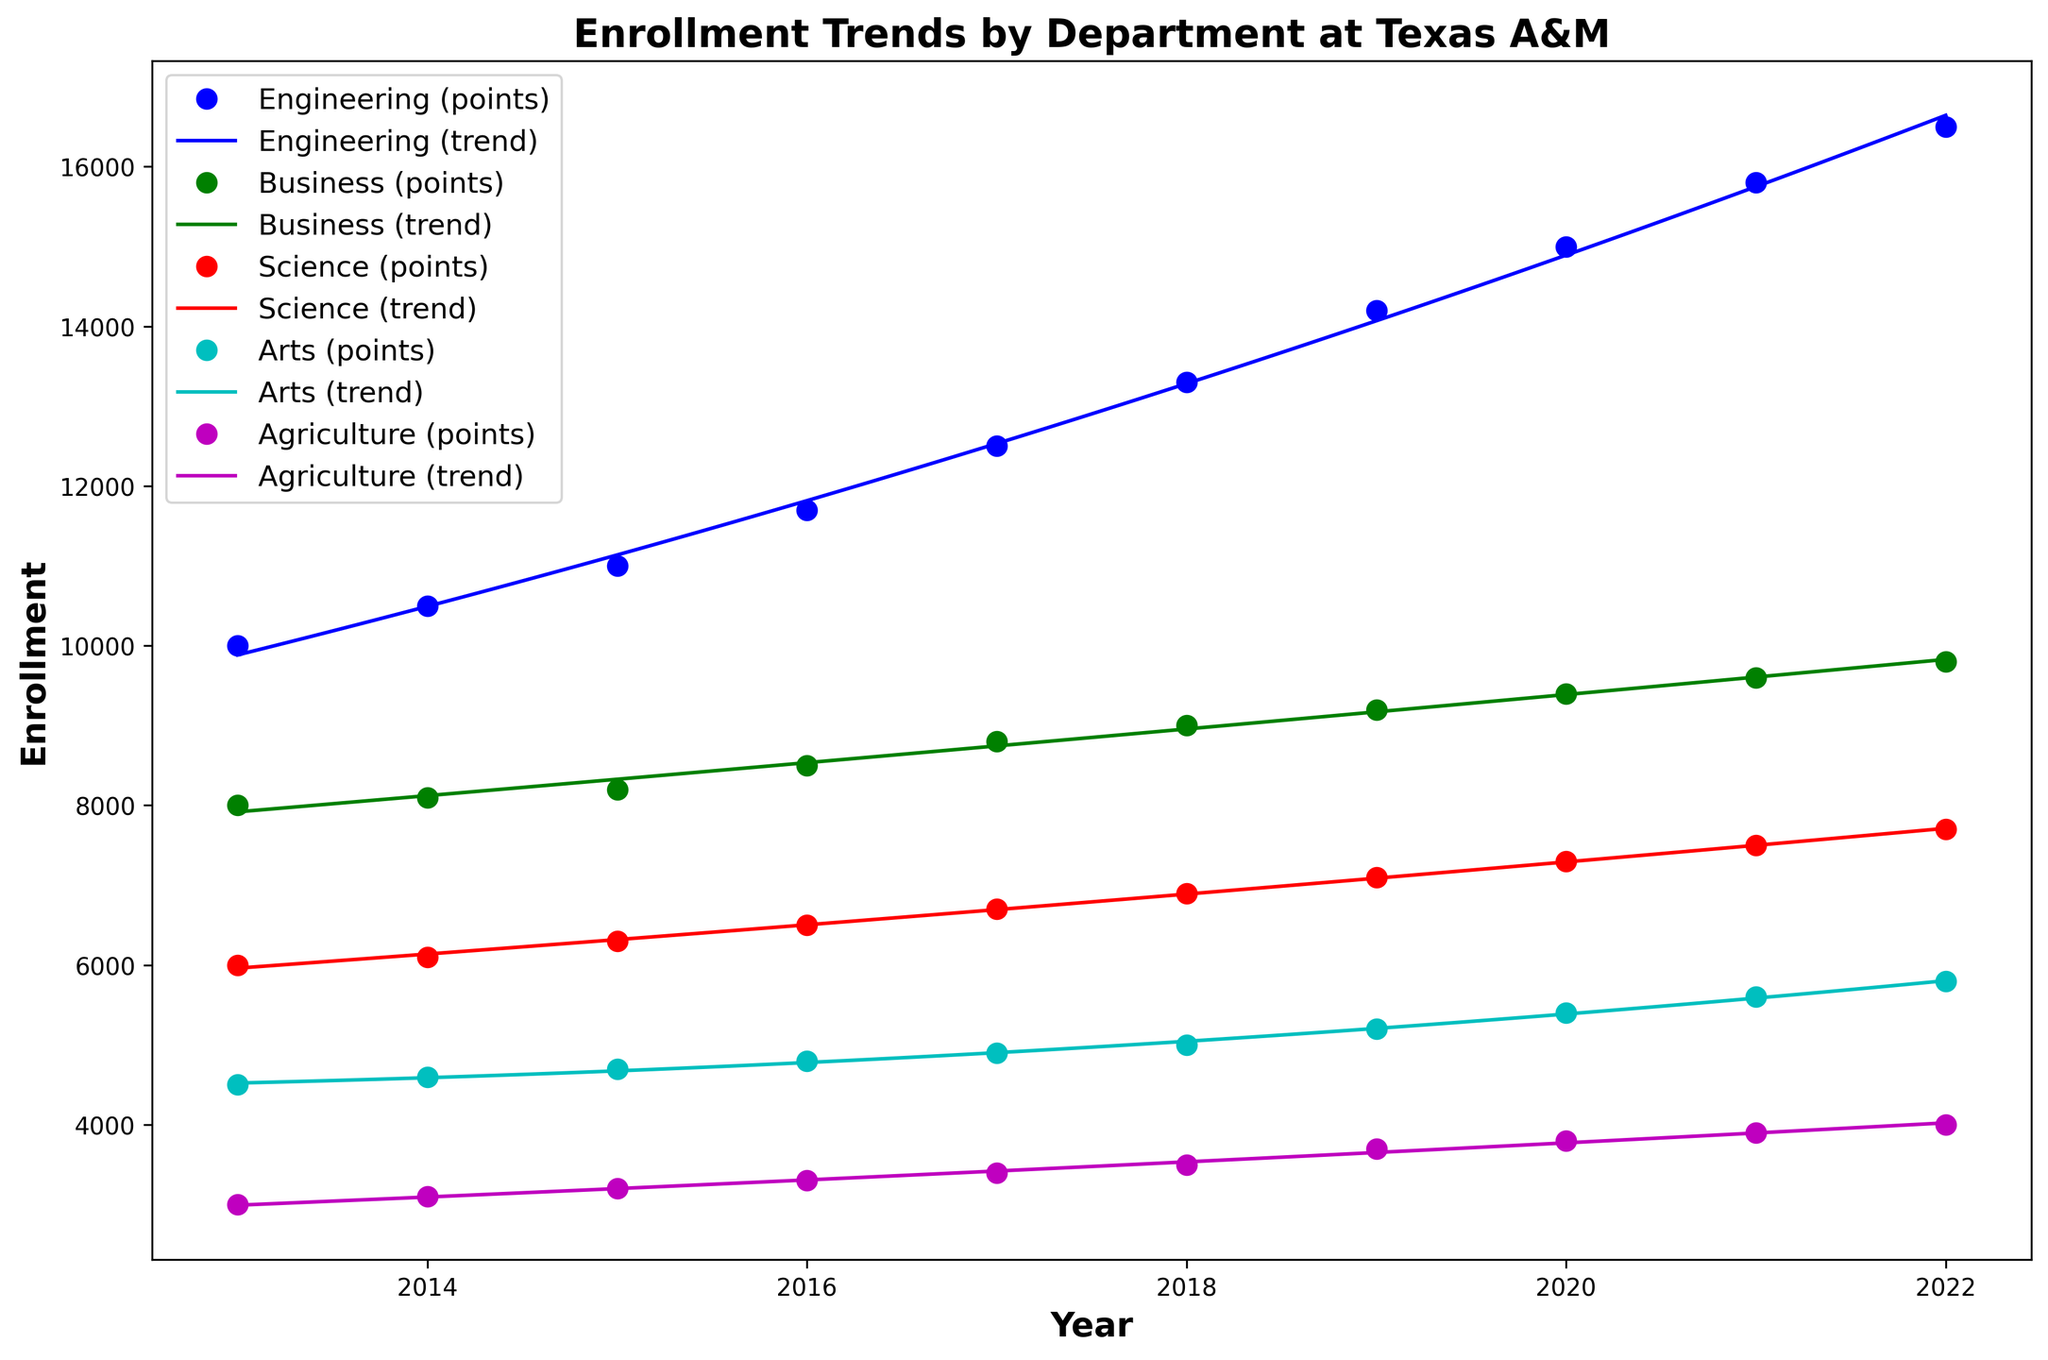Which department showed the highest enrollment increase from 2013 to 2022? By comparing the enrollment values in 2013 and 2022 for each department, Engineering had the largest difference. Engineering grew from 10,000 to 16,500, an increase of 6,500.
Answer: Engineering Which department had the smallest polynomial curve trend? By observing the curves, Agriculture's curve appears less steep compared to others, indicating a smaller increase in the trend over time.
Answer: Agriculture Among the departments, which one had the most consistent increase in enrollment over the years? The Business department shows a relatively stable and steady increase in the scatter points and fitted curve from 2013 to 2022.
Answer: Business What is the average enrollment in the Science department for the given years? The enrollment values for Science are [6000, 6100, 6300, 6500, 6700, 6900, 7100, 7300, 7500, 7700]. The sum of these values is 73100. Dividing by 10 years gives an average of 7310.
Answer: 7310 Based on visual trend lines, which two departments intersect in their polynomial trend curve, if at all? The polynomial trend lines for Business and Science appear to intersect around the year 2022.
Answer: Business and Science How many departments have trend lines that appear to have quadratic fits? Observing the curves, all five departments (Engineering, Business, Science, Arts, and Agriculture) have quadratic polynomial fits as their curves are parabolic.
Answer: 5 What is the total enrollment for the Arts department across the entire data range? The enrollment values for Arts from 2013 to 2022 are [4500, 4600, 4700, 4800, 4900, 5000, 5200, 5400, 5600, 5800]. Adding these values gives a total of 50500.
Answer: 50500 Which department's enrollment shows the greatest deviation from its trendline in any particular year? By comparing the points and trend lines, Engineering in 2020 shows a point that deviates notably from the trend line.
Answer: Engineering (2020) Which color represents the Business department, and how can you tell? The Business department is represented by the green color. This can be identified by matching the color of the points and the trend line to the legend.
Answer: Green 